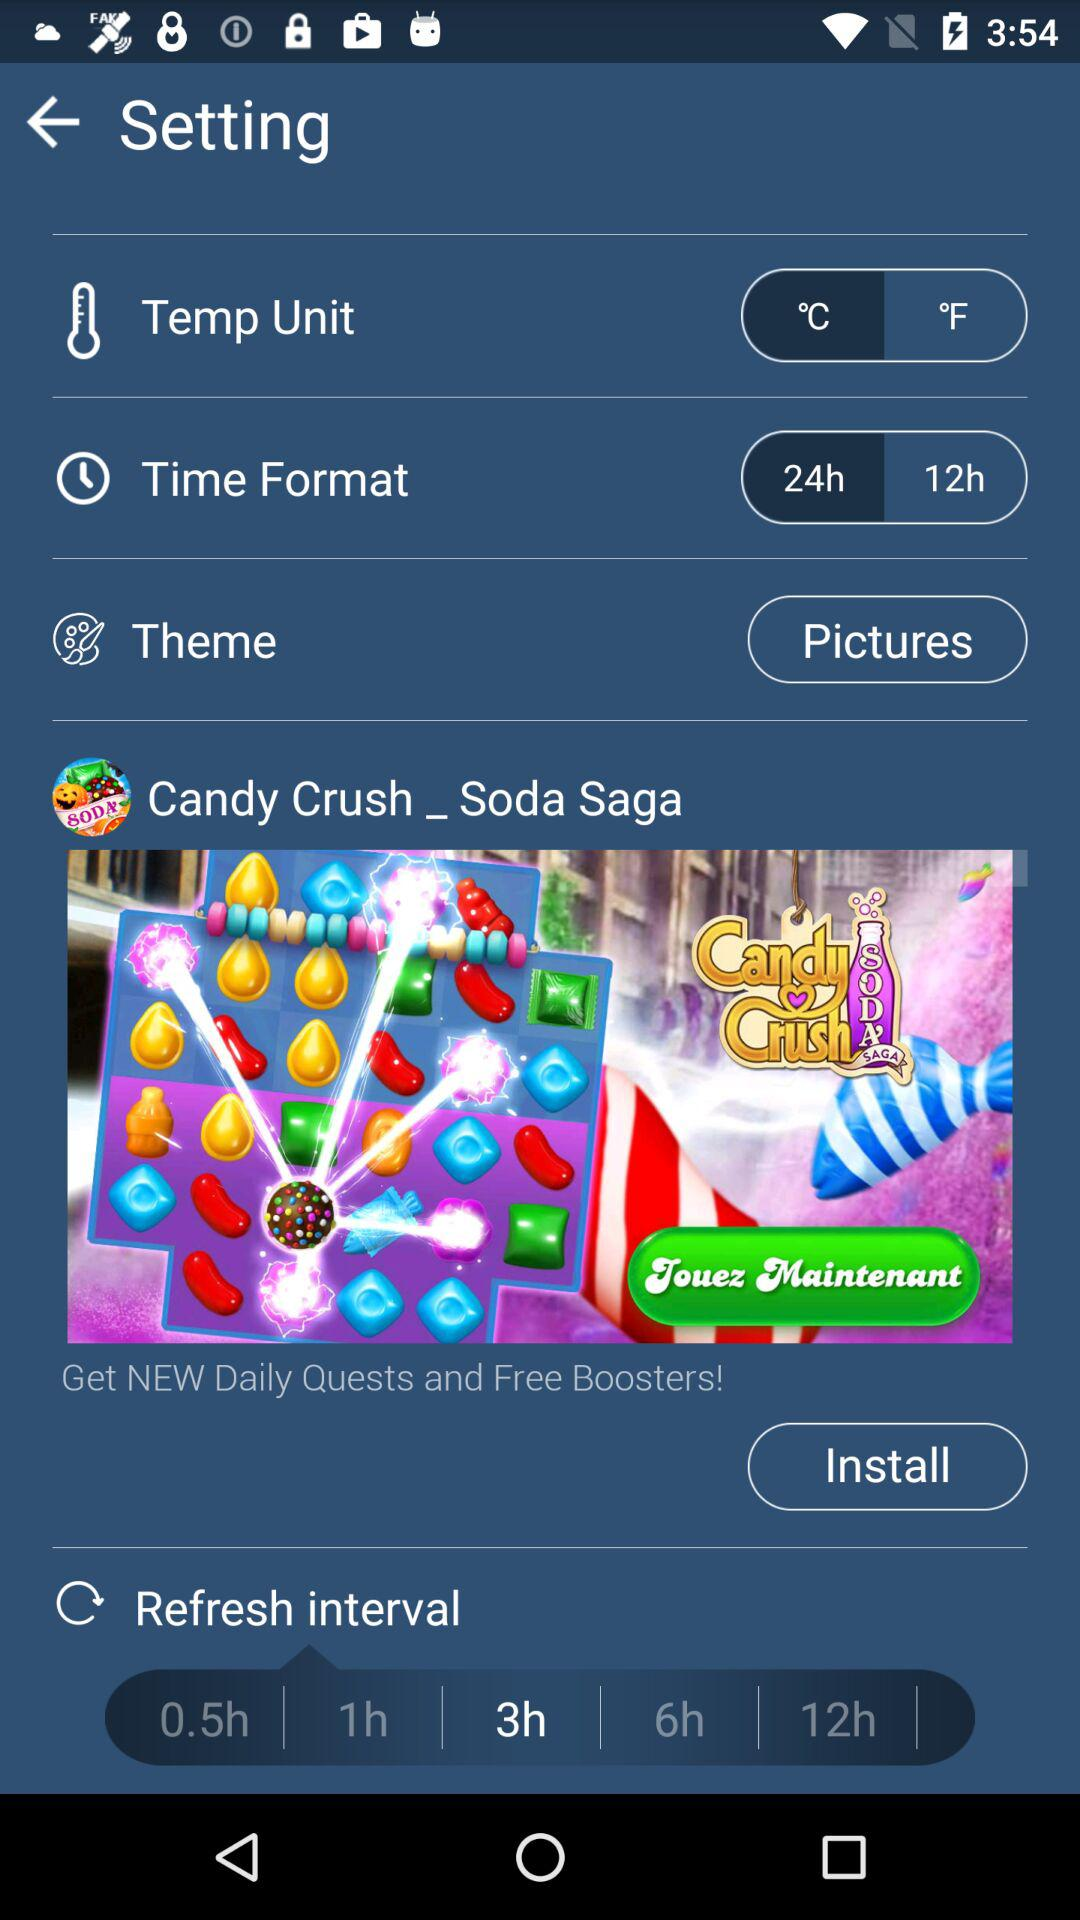What is the highlighted time for "Refresh interval"? The highlighted time is 3 hours. 